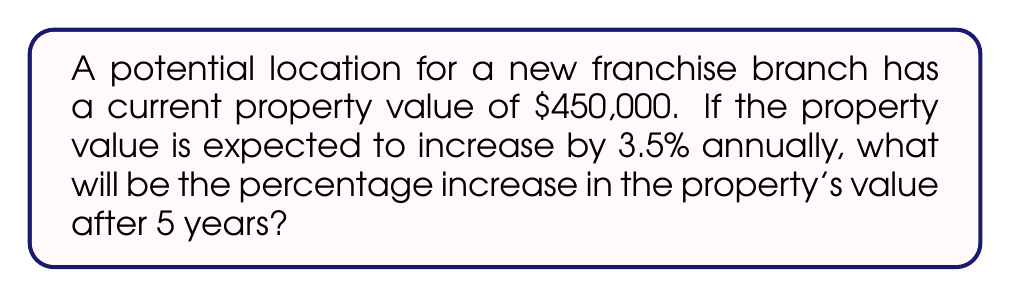Give your solution to this math problem. To solve this problem, we'll follow these steps:

1) First, let's calculate the property value after 5 years:
   Initial value: $450,000
   Annual increase: 3.5% = 0.035
   Time: 5 years

   We can use the compound interest formula:
   $$A = P(1 + r)^t$$
   Where:
   $A$ = Final amount
   $P$ = Principal (initial value)
   $r$ = Annual rate of increase
   $t$ = Time in years

   $$A = 450,000(1 + 0.035)^5$$
   $$A = 450,000(1.035)^5$$
   $$A = 450,000(1.187686)$$
   $$A = 534,458.70$$

2) Now, let's calculate the total increase in value:
   $$\text{Increase} = \text{Final Value} - \text{Initial Value}$$
   $$\text{Increase} = 534,458.70 - 450,000 = 84,458.70$$

3) To find the percentage increase, we use the formula:
   $$\text{Percentage Increase} = \frac{\text{Increase}}{\text{Initial Value}} \times 100\%$$

   $$\text{Percentage Increase} = \frac{84,458.70}{450,000} \times 100\%$$
   $$\text{Percentage Increase} = 0.187686 \times 100\%$$
   $$\text{Percentage Increase} = 18.7686\%$$

4) Rounding to two decimal places:
   Percentage Increase ≈ 18.77%
Answer: 18.77% 